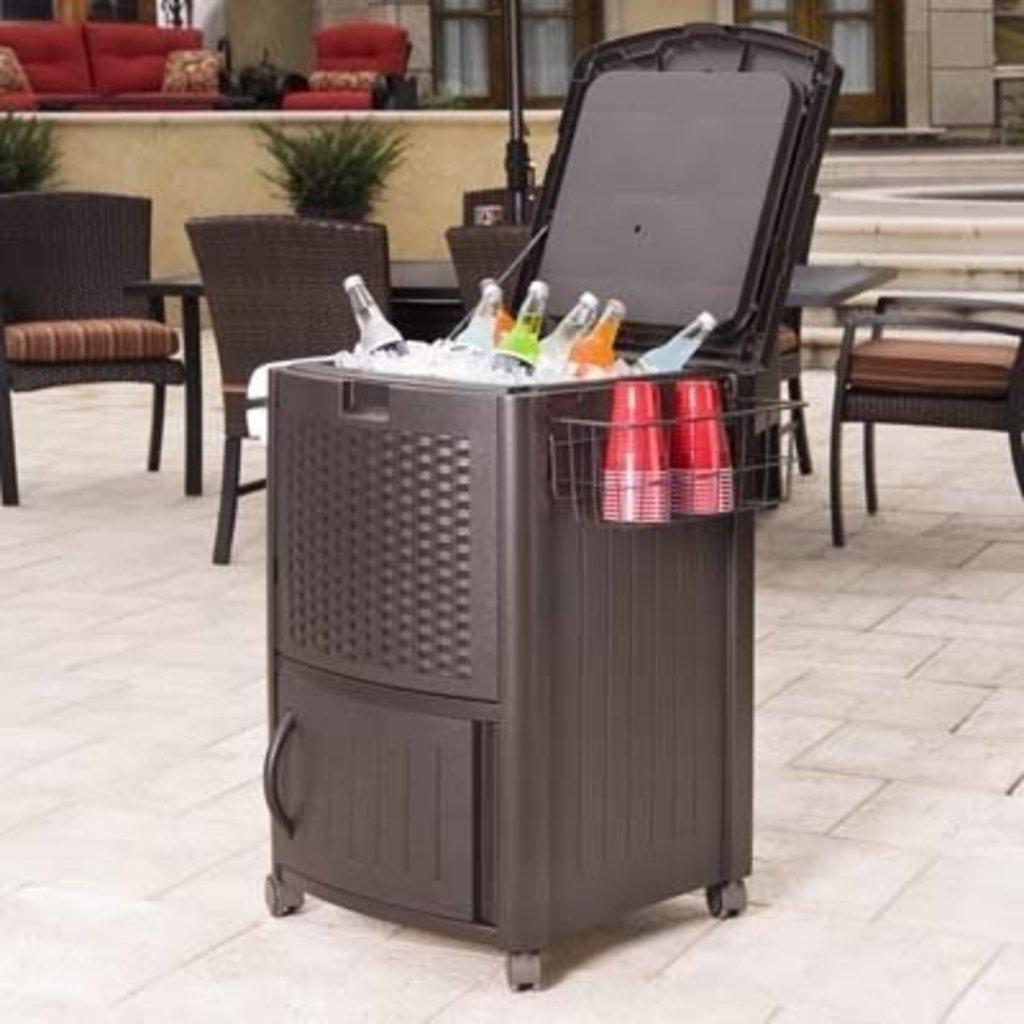Please provide a concise description of this image. In this picture we can see a patio cooler and on the cooler there are bottles and on the right side of the cooler there are cups. Behind the cooler there are chairs, couch, plants, windows and other things. 